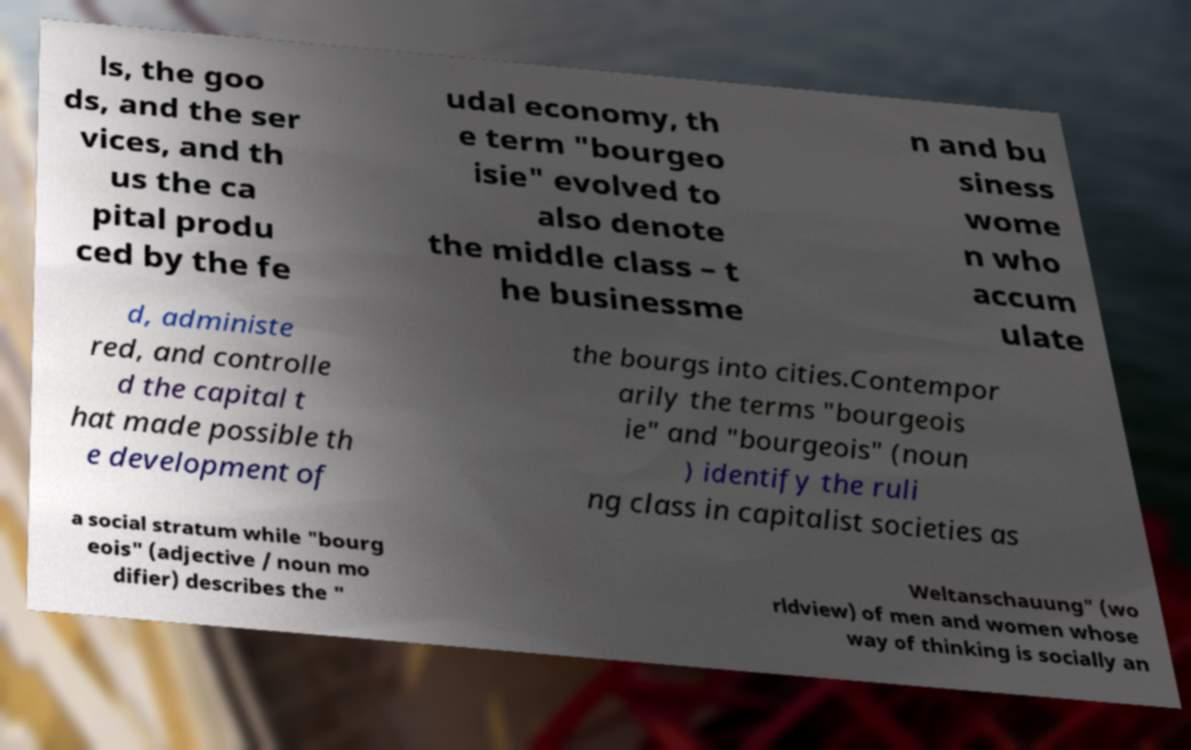Could you extract and type out the text from this image? ls, the goo ds, and the ser vices, and th us the ca pital produ ced by the fe udal economy, th e term "bourgeo isie" evolved to also denote the middle class – t he businessme n and bu siness wome n who accum ulate d, administe red, and controlle d the capital t hat made possible th e development of the bourgs into cities.Contempor arily the terms "bourgeois ie" and "bourgeois" (noun ) identify the ruli ng class in capitalist societies as a social stratum while "bourg eois" (adjective / noun mo difier) describes the " Weltanschauung" (wo rldview) of men and women whose way of thinking is socially an 